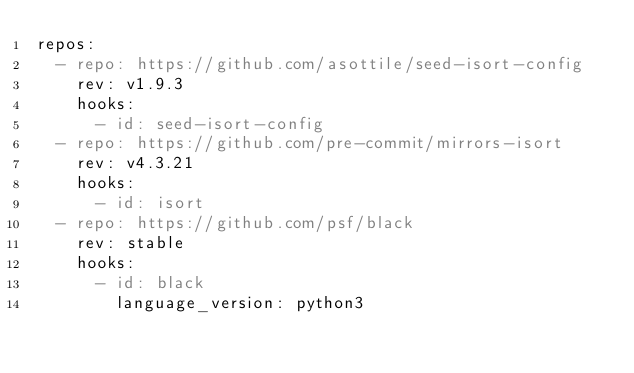Convert code to text. <code><loc_0><loc_0><loc_500><loc_500><_YAML_>repos:
  - repo: https://github.com/asottile/seed-isort-config
    rev: v1.9.3
    hooks:
      - id: seed-isort-config
  - repo: https://github.com/pre-commit/mirrors-isort
    rev: v4.3.21
    hooks:
      - id: isort
  - repo: https://github.com/psf/black
    rev: stable
    hooks:
      - id: black
        language_version: python3
</code> 